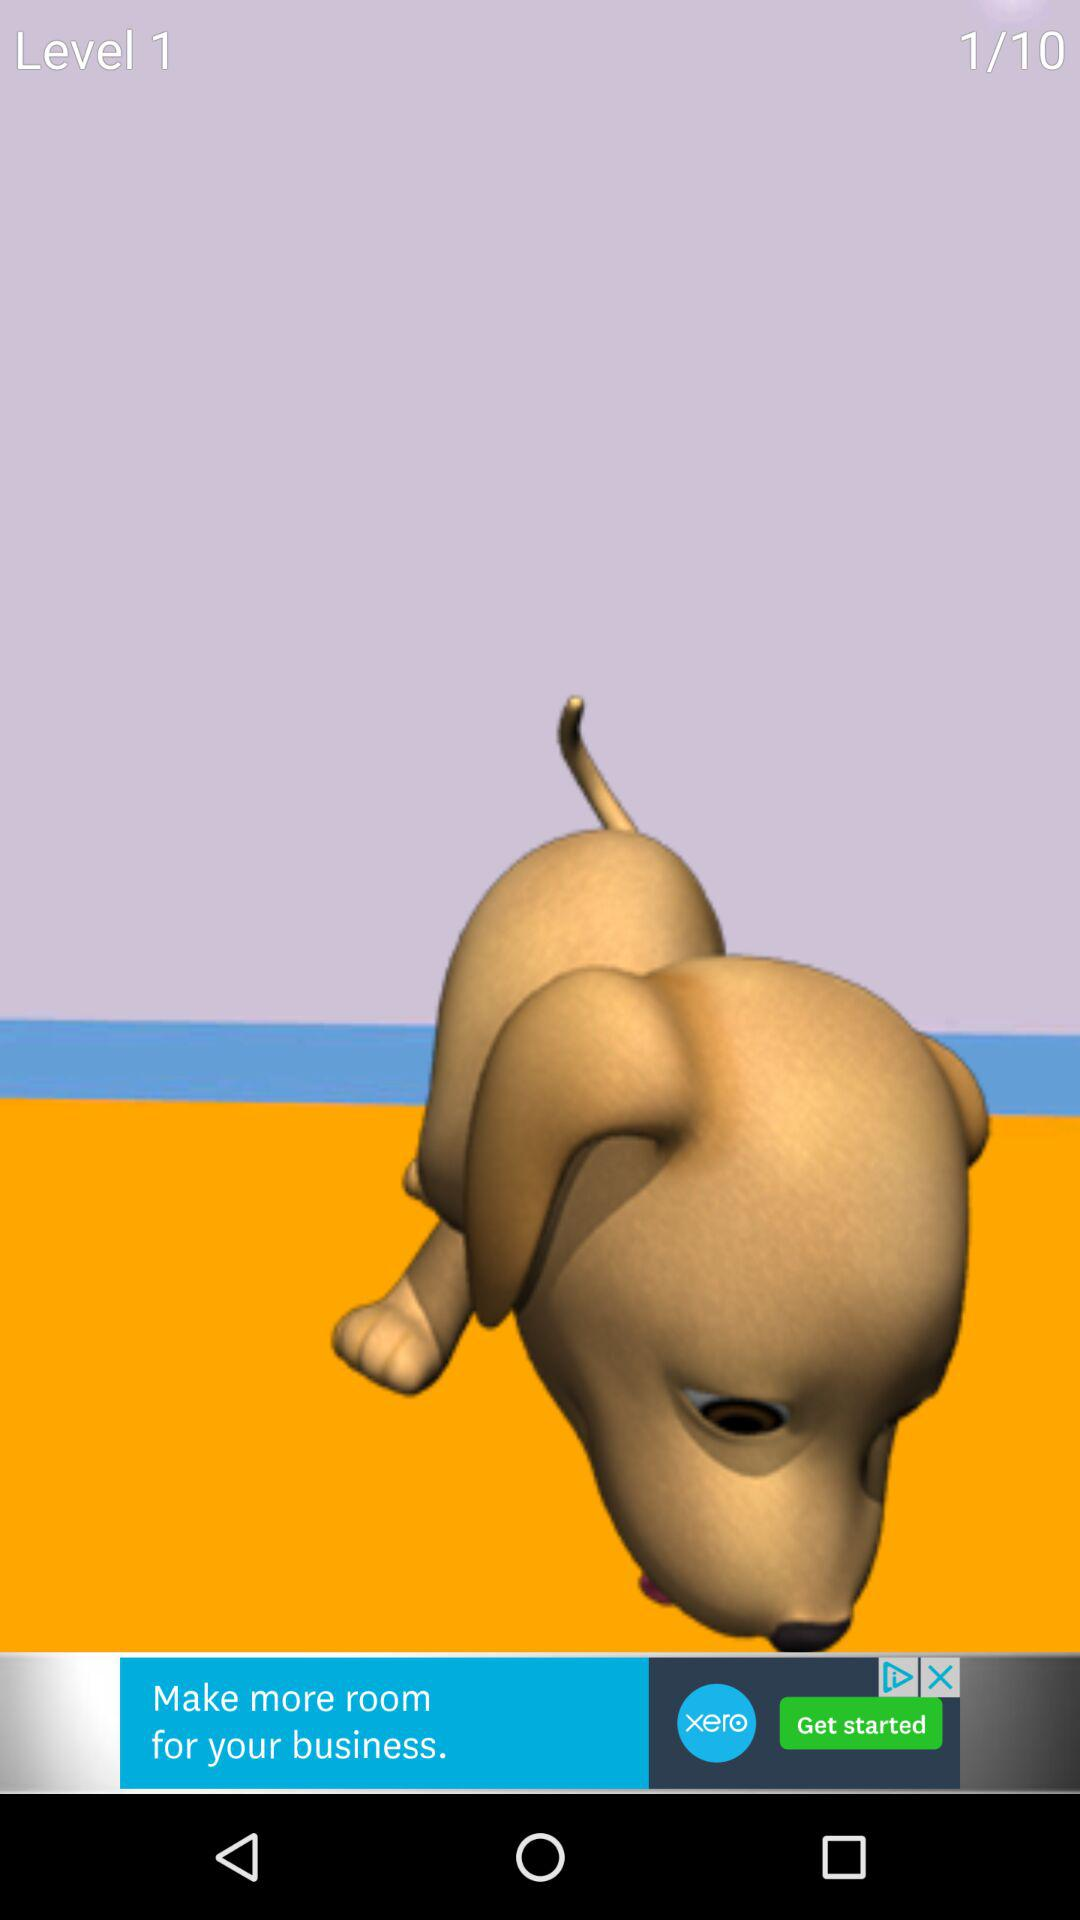What is the total number of levels? The total number of levels is 10. 